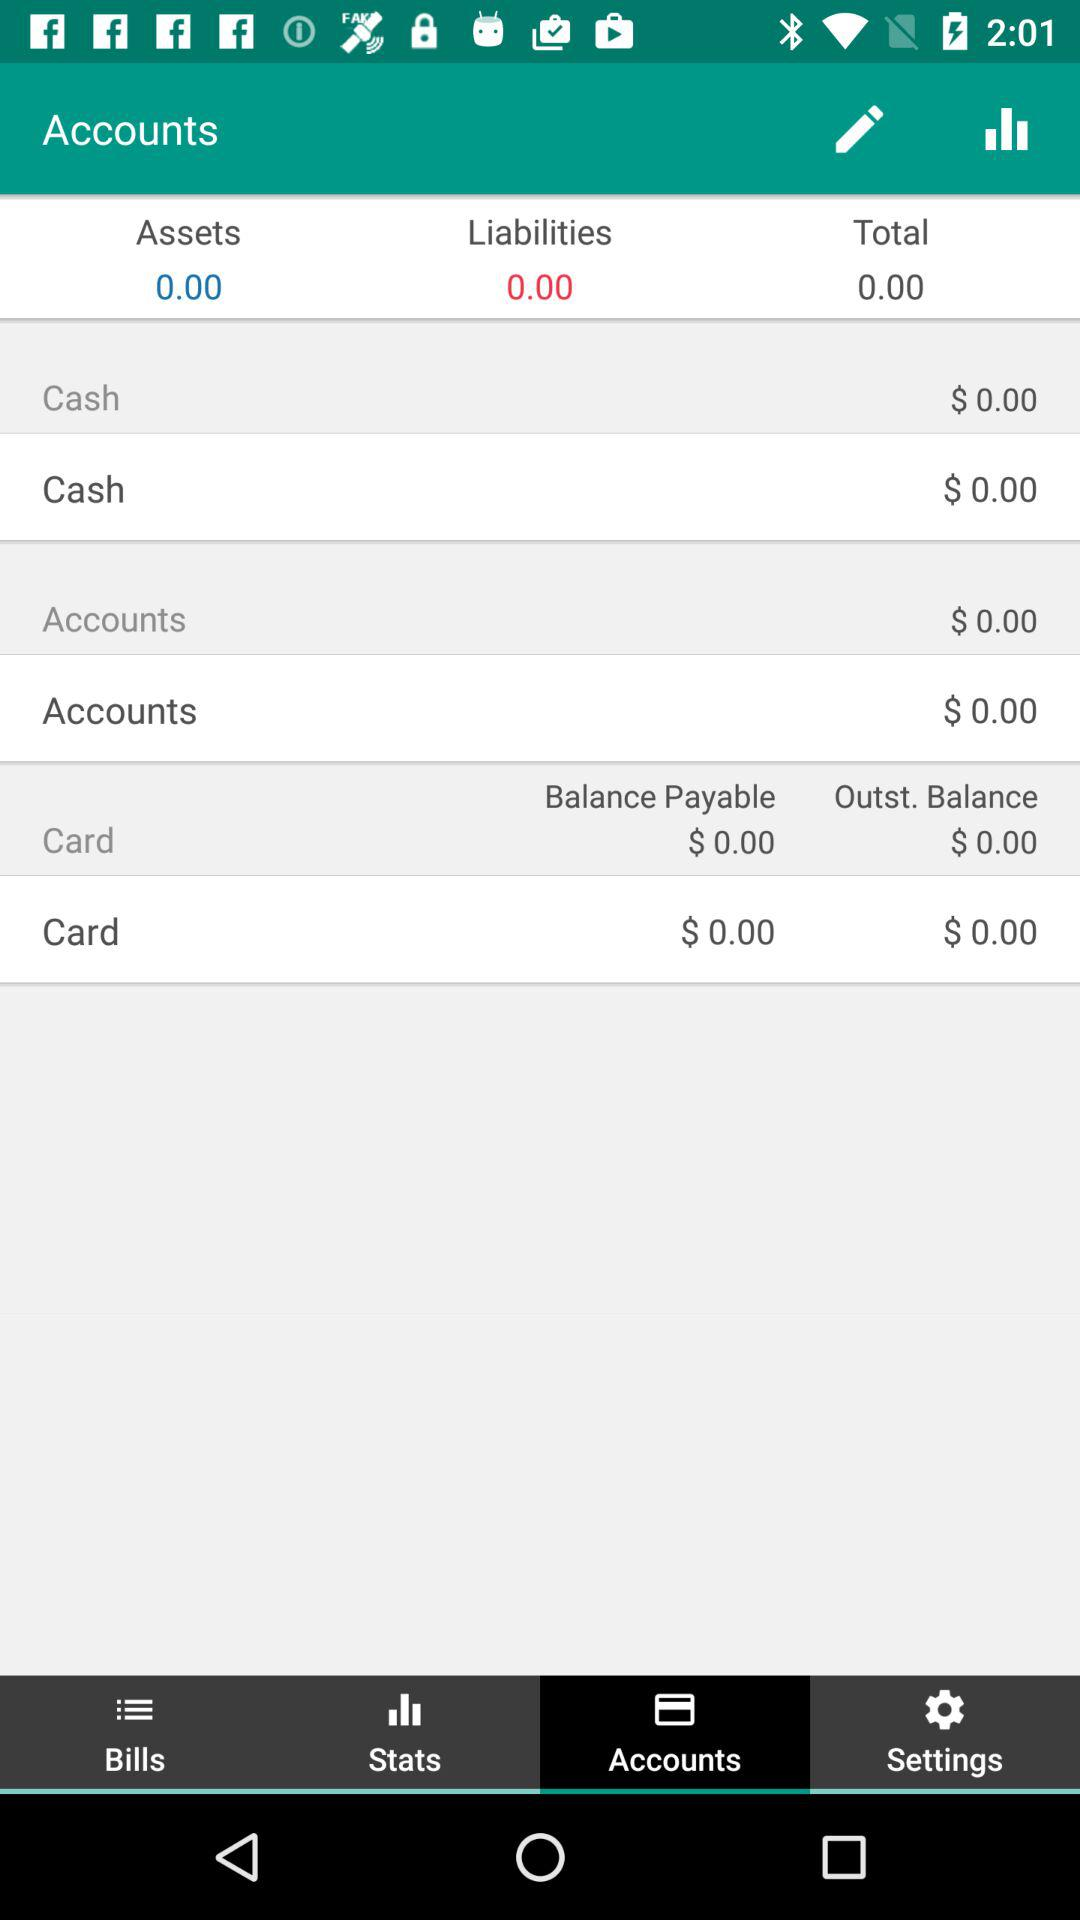What balance is payable? The payable balance is $0. 